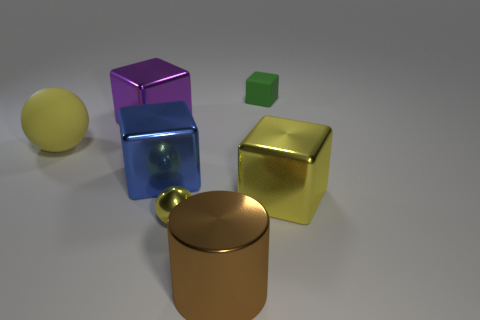There is another rubber thing that is the same size as the brown thing; what color is it?
Offer a very short reply. Yellow. What number of gray objects are either tiny metal things or shiny blocks?
Your answer should be compact. 0. Are there more small purple cubes than large yellow blocks?
Make the answer very short. No. There is a metal block on the right side of the big brown metal object; does it have the same size as the yellow metal thing left of the large brown object?
Ensure brevity in your answer.  No. There is a sphere that is in front of the big shiny cube right of the small object on the right side of the yellow metallic ball; what is its color?
Your response must be concise. Yellow. Is there another metallic object of the same shape as the small green object?
Your answer should be very brief. Yes. Is the number of metal cubes that are in front of the large yellow sphere greater than the number of large cyan metal spheres?
Provide a short and direct response. Yes. How many shiny things are either tiny blocks or big cyan balls?
Ensure brevity in your answer.  0. What size is the cube that is on the right side of the purple metal cube and left of the tiny shiny thing?
Your response must be concise. Large. Is there a sphere on the right side of the metal cube on the right side of the brown cylinder?
Keep it short and to the point. No. 